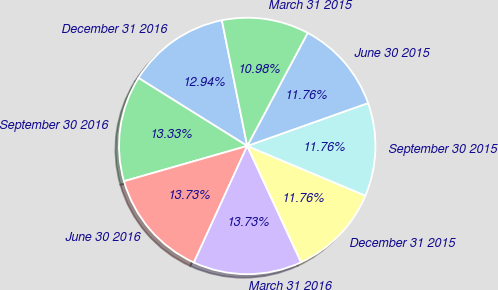Convert chart. <chart><loc_0><loc_0><loc_500><loc_500><pie_chart><fcel>December 31 2016<fcel>September 30 2016<fcel>June 30 2016<fcel>March 31 2016<fcel>December 31 2015<fcel>September 30 2015<fcel>June 30 2015<fcel>March 31 2015<nl><fcel>12.94%<fcel>13.33%<fcel>13.73%<fcel>13.73%<fcel>11.76%<fcel>11.76%<fcel>11.76%<fcel>10.98%<nl></chart> 